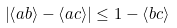Convert formula to latex. <formula><loc_0><loc_0><loc_500><loc_500>\left | \left \langle a b \right \rangle - \left \langle a c \right \rangle \right | \leq 1 - \left \langle b c \right \rangle</formula> 